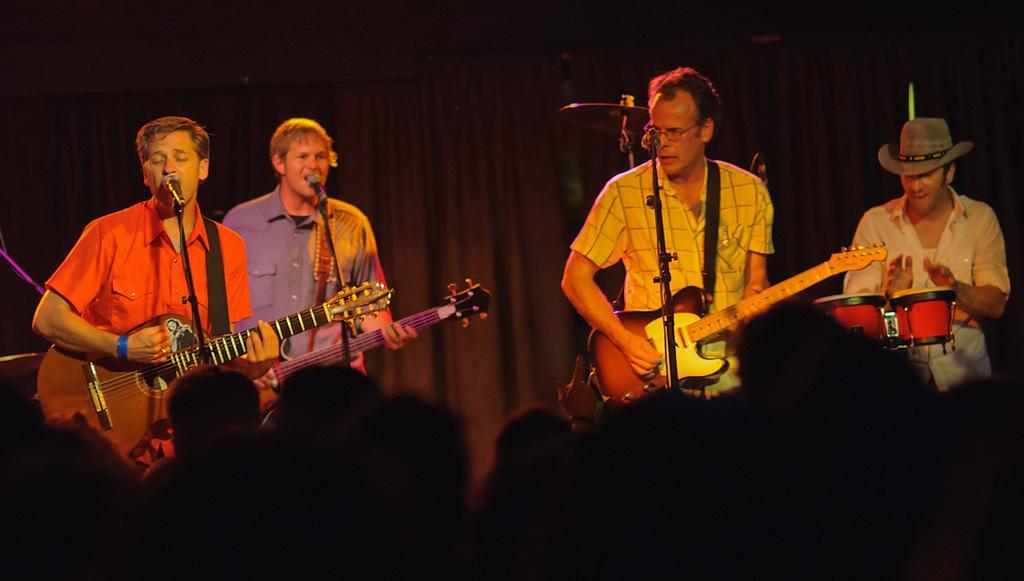Please provide a concise description of this image. there is a music show going on. there are 4 men standing. there people in the front are playing guitar. the people at the left are singing. the person at the right corner is playing drums. 